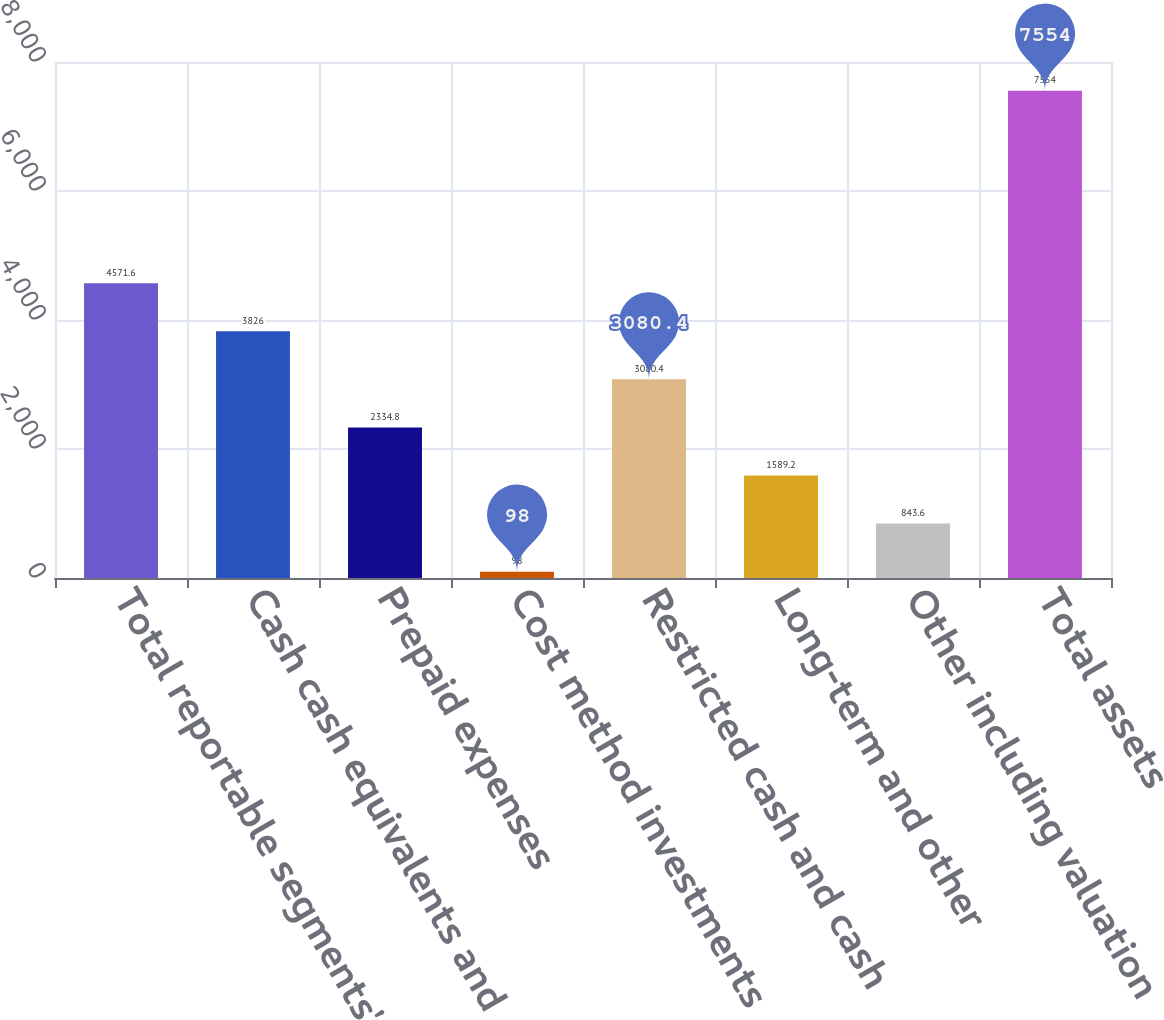<chart> <loc_0><loc_0><loc_500><loc_500><bar_chart><fcel>Total reportable segments'<fcel>Cash cash equivalents and<fcel>Prepaid expenses<fcel>Cost method investments<fcel>Restricted cash and cash<fcel>Long-term and other<fcel>Other including valuation<fcel>Total assets<nl><fcel>4571.6<fcel>3826<fcel>2334.8<fcel>98<fcel>3080.4<fcel>1589.2<fcel>843.6<fcel>7554<nl></chart> 